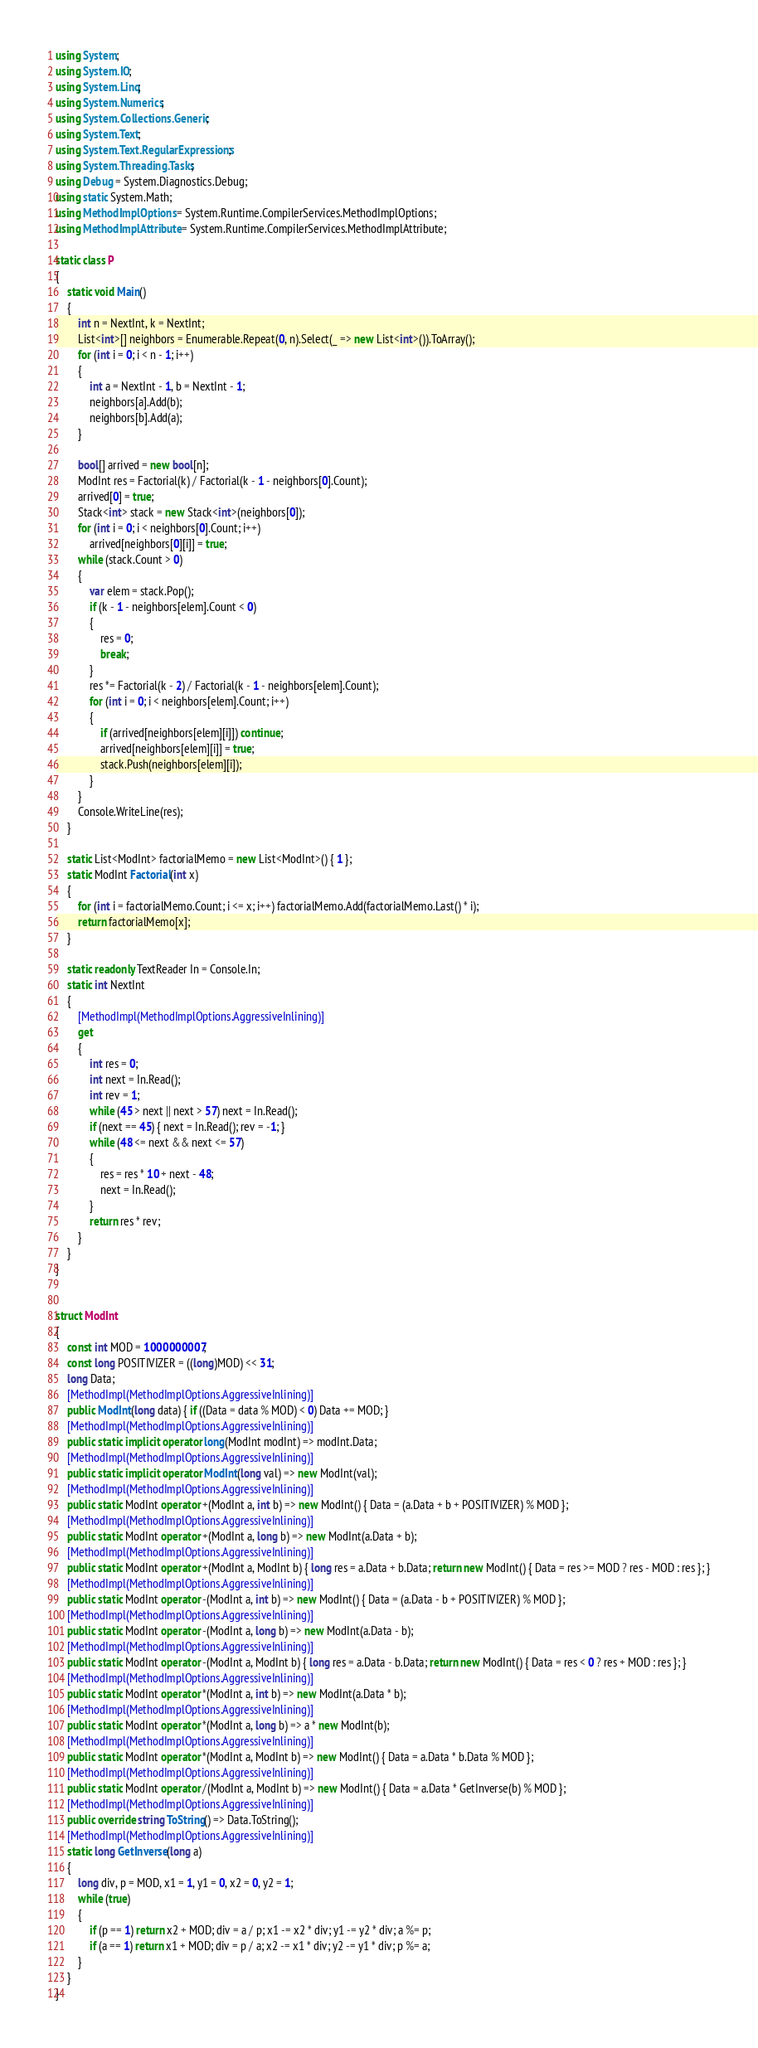<code> <loc_0><loc_0><loc_500><loc_500><_C#_>using System;
using System.IO;
using System.Linq;
using System.Numerics;
using System.Collections.Generic;
using System.Text;
using System.Text.RegularExpressions;
using System.Threading.Tasks;
using Debug = System.Diagnostics.Debug;
using static System.Math;
using MethodImplOptions = System.Runtime.CompilerServices.MethodImplOptions;
using MethodImplAttribute = System.Runtime.CompilerServices.MethodImplAttribute;

static class P
{
    static void Main()
    {
        int n = NextInt, k = NextInt;
        List<int>[] neighbors = Enumerable.Repeat(0, n).Select(_ => new List<int>()).ToArray();
        for (int i = 0; i < n - 1; i++)
        {
            int a = NextInt - 1, b = NextInt - 1;
            neighbors[a].Add(b);
            neighbors[b].Add(a);
        }

        bool[] arrived = new bool[n];
        ModInt res = Factorial(k) / Factorial(k - 1 - neighbors[0].Count);
        arrived[0] = true;
        Stack<int> stack = new Stack<int>(neighbors[0]);
        for (int i = 0; i < neighbors[0].Count; i++)
            arrived[neighbors[0][i]] = true;
        while (stack.Count > 0)
        {
            var elem = stack.Pop();
            if (k - 1 - neighbors[elem].Count < 0)
            {
                res = 0;
                break;
            }
            res *= Factorial(k - 2) / Factorial(k - 1 - neighbors[elem].Count);
            for (int i = 0; i < neighbors[elem].Count; i++)
            {
                if (arrived[neighbors[elem][i]]) continue;
                arrived[neighbors[elem][i]] = true;
                stack.Push(neighbors[elem][i]);
            }
        }
        Console.WriteLine(res);
    }

    static List<ModInt> factorialMemo = new List<ModInt>() { 1 };
    static ModInt Factorial(int x)
    {
        for (int i = factorialMemo.Count; i <= x; i++) factorialMemo.Add(factorialMemo.Last() * i);
        return factorialMemo[x];
    }

    static readonly TextReader In = Console.In;
    static int NextInt
    {
        [MethodImpl(MethodImplOptions.AggressiveInlining)]
        get
        {
            int res = 0;
            int next = In.Read();
            int rev = 1;
            while (45 > next || next > 57) next = In.Read();
            if (next == 45) { next = In.Read(); rev = -1; }
            while (48 <= next && next <= 57)
            {
                res = res * 10 + next - 48;
                next = In.Read();
            }
            return res * rev;
        }
    }
}


struct ModInt
{
    const int MOD = 1000000007;
    const long POSITIVIZER = ((long)MOD) << 31;
    long Data;
    [MethodImpl(MethodImplOptions.AggressiveInlining)]
    public ModInt(long data) { if ((Data = data % MOD) < 0) Data += MOD; }
    [MethodImpl(MethodImplOptions.AggressiveInlining)]
    public static implicit operator long(ModInt modInt) => modInt.Data;
    [MethodImpl(MethodImplOptions.AggressiveInlining)]
    public static implicit operator ModInt(long val) => new ModInt(val);
    [MethodImpl(MethodImplOptions.AggressiveInlining)]
    public static ModInt operator +(ModInt a, int b) => new ModInt() { Data = (a.Data + b + POSITIVIZER) % MOD };
    [MethodImpl(MethodImplOptions.AggressiveInlining)]
    public static ModInt operator +(ModInt a, long b) => new ModInt(a.Data + b);
    [MethodImpl(MethodImplOptions.AggressiveInlining)]
    public static ModInt operator +(ModInt a, ModInt b) { long res = a.Data + b.Data; return new ModInt() { Data = res >= MOD ? res - MOD : res }; }
    [MethodImpl(MethodImplOptions.AggressiveInlining)]
    public static ModInt operator -(ModInt a, int b) => new ModInt() { Data = (a.Data - b + POSITIVIZER) % MOD };
    [MethodImpl(MethodImplOptions.AggressiveInlining)]
    public static ModInt operator -(ModInt a, long b) => new ModInt(a.Data - b);
    [MethodImpl(MethodImplOptions.AggressiveInlining)]
    public static ModInt operator -(ModInt a, ModInt b) { long res = a.Data - b.Data; return new ModInt() { Data = res < 0 ? res + MOD : res }; }
    [MethodImpl(MethodImplOptions.AggressiveInlining)]
    public static ModInt operator *(ModInt a, int b) => new ModInt(a.Data * b);
    [MethodImpl(MethodImplOptions.AggressiveInlining)]
    public static ModInt operator *(ModInt a, long b) => a * new ModInt(b);
    [MethodImpl(MethodImplOptions.AggressiveInlining)]
    public static ModInt operator *(ModInt a, ModInt b) => new ModInt() { Data = a.Data * b.Data % MOD };
    [MethodImpl(MethodImplOptions.AggressiveInlining)]
    public static ModInt operator /(ModInt a, ModInt b) => new ModInt() { Data = a.Data * GetInverse(b) % MOD };
    [MethodImpl(MethodImplOptions.AggressiveInlining)]
    public override string ToString() => Data.ToString();
    [MethodImpl(MethodImplOptions.AggressiveInlining)]
    static long GetInverse(long a)
    {
        long div, p = MOD, x1 = 1, y1 = 0, x2 = 0, y2 = 1;
        while (true)
        {
            if (p == 1) return x2 + MOD; div = a / p; x1 -= x2 * div; y1 -= y2 * div; a %= p;
            if (a == 1) return x1 + MOD; div = p / a; x2 -= x1 * div; y2 -= y1 * div; p %= a;
        }
    }
}
</code> 